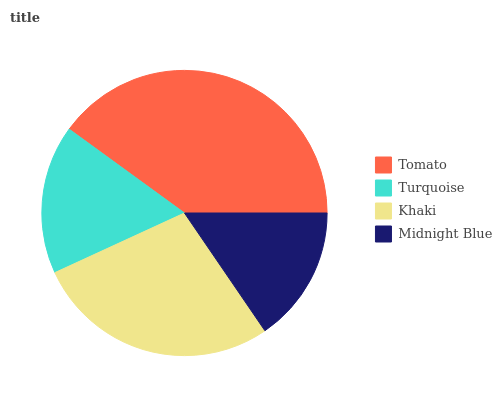Is Midnight Blue the minimum?
Answer yes or no. Yes. Is Tomato the maximum?
Answer yes or no. Yes. Is Turquoise the minimum?
Answer yes or no. No. Is Turquoise the maximum?
Answer yes or no. No. Is Tomato greater than Turquoise?
Answer yes or no. Yes. Is Turquoise less than Tomato?
Answer yes or no. Yes. Is Turquoise greater than Tomato?
Answer yes or no. No. Is Tomato less than Turquoise?
Answer yes or no. No. Is Khaki the high median?
Answer yes or no. Yes. Is Turquoise the low median?
Answer yes or no. Yes. Is Turquoise the high median?
Answer yes or no. No. Is Midnight Blue the low median?
Answer yes or no. No. 